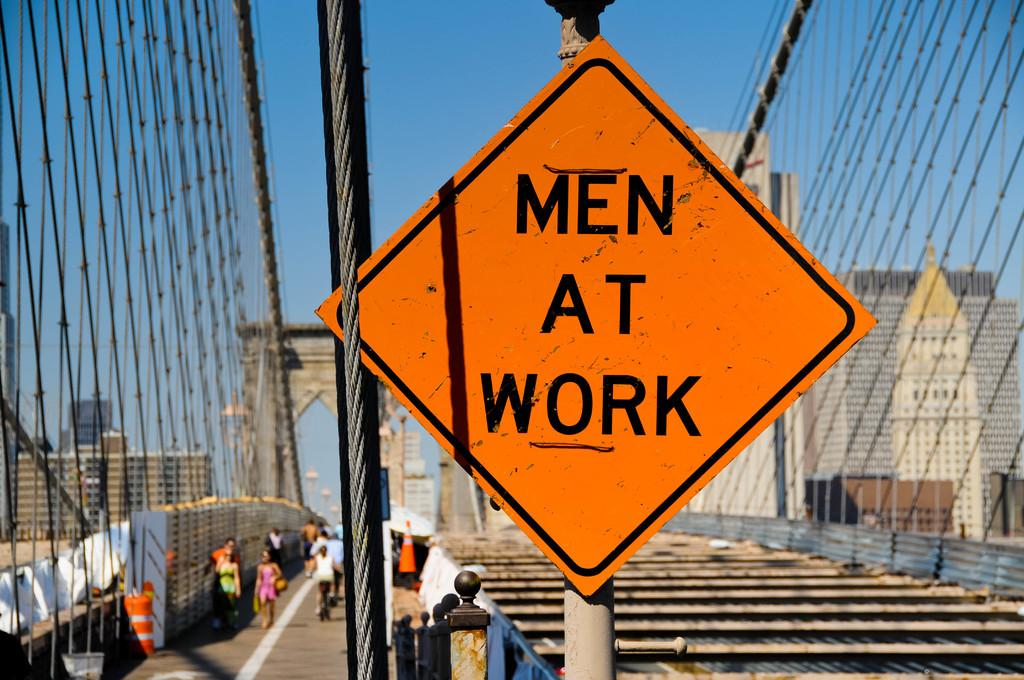<image>
Offer a succinct explanation of the picture presented. A large orange Men At Work sign on a bridge under construction. 